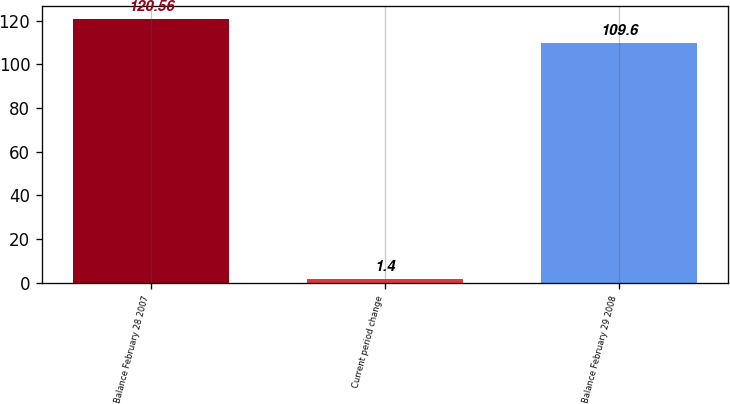Convert chart. <chart><loc_0><loc_0><loc_500><loc_500><bar_chart><fcel>Balance February 28 2007<fcel>Current period change<fcel>Balance February 29 2008<nl><fcel>120.56<fcel>1.4<fcel>109.6<nl></chart> 